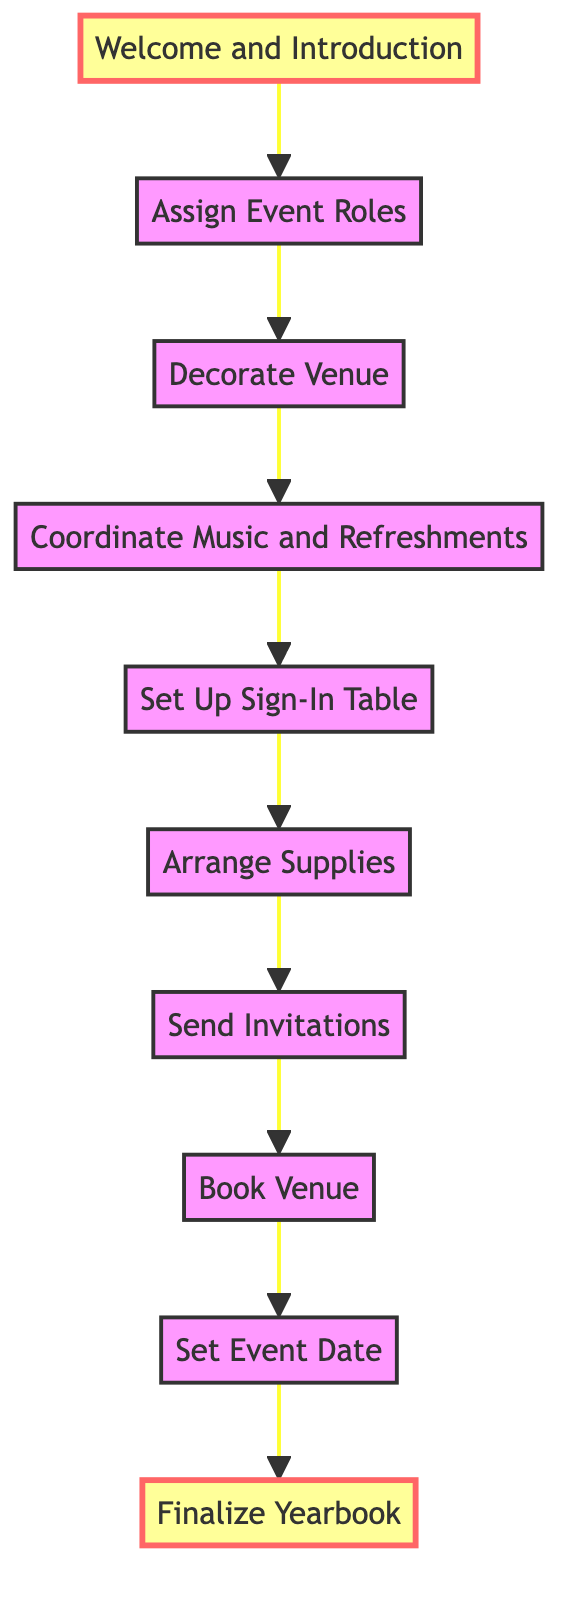What is the first step in organizing the event? The first step in organizing the event, as shown in the diagram, is "Welcome and Introduction." This is the topmost node, indicating it occurs first in the flow of events.
Answer: Welcome and Introduction How many steps are there in total for the event? Counting all the nodes in the flowchart, there are a total of 10 steps indicated in the diagram.
Answer: 10 What step comes immediately after "Send Invitations"? The step that follows "Send Invitations" is "Book Venue." The diagram clearly shows the directional flow from one step to the next.
Answer: Book Venue Which step involves preparing supplies? The step that involves preparing supplies is "Arrange Supplies." This is indicated clearly in the flow of steps following "Set Up Sign-In Table."
Answer: Arrange Supplies What is the last step in the event organization process? The last step in the event process is "Finalize Yearbook." It appears at the bottom of the flow, which indicates it is the final action taken in this sequence.
Answer: Finalize Yearbook What activities are coordinated after "Decorate Venue"? The activity coordinated after "Decorate Venue" is "Coordinate Music and Refreshments." This shows the continuation of planning activities that enhance the event experience.
Answer: Coordinate Music and Refreshments Which two steps are highlighted in the diagram? The two highlighted steps in the diagram are "Welcome and Introduction" at the top and "Finalize Yearbook" at the bottom, signifying their importance in the flow.
Answer: Welcome and Introduction, Finalize Yearbook What is required to be done before sending invitations? Before sending invitations, "Arrange Supplies" needs to be completed, as the flowchart indicates that this step must be done first.
Answer: Arrange Supplies Which step focuses on tracking attendance? The step that focuses on tracking attendance is "Set Up Sign-In Table." This is indicated clearly as part of organizing the event's logistics.
Answer: Set Up Sign-In Table 